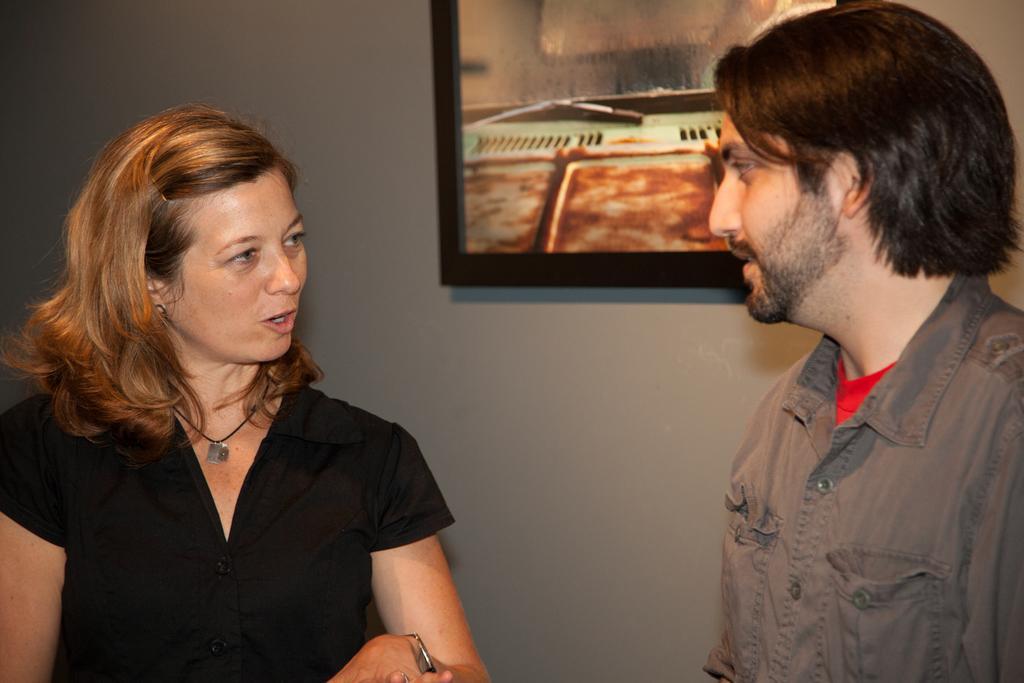Please provide a concise description of this image. In this picture there is a man who is standing on the right side of the image and there is a woman on the left side of the image, there is a portrait on the wall in the center of the image. 